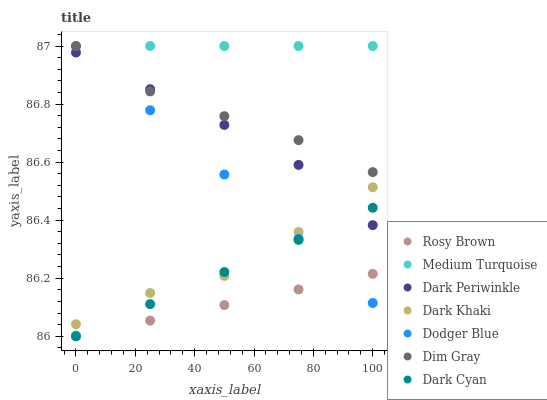Does Rosy Brown have the minimum area under the curve?
Answer yes or no. Yes. Does Medium Turquoise have the maximum area under the curve?
Answer yes or no. Yes. Does Dark Khaki have the minimum area under the curve?
Answer yes or no. No. Does Dark Khaki have the maximum area under the curve?
Answer yes or no. No. Is Rosy Brown the smoothest?
Answer yes or no. Yes. Is Medium Turquoise the roughest?
Answer yes or no. Yes. Is Dark Khaki the smoothest?
Answer yes or no. No. Is Dark Khaki the roughest?
Answer yes or no. No. Does Rosy Brown have the lowest value?
Answer yes or no. Yes. Does Dark Khaki have the lowest value?
Answer yes or no. No. Does Medium Turquoise have the highest value?
Answer yes or no. Yes. Does Dark Khaki have the highest value?
Answer yes or no. No. Is Dark Cyan less than Medium Turquoise?
Answer yes or no. Yes. Is Medium Turquoise greater than Rosy Brown?
Answer yes or no. Yes. Does Dodger Blue intersect Dim Gray?
Answer yes or no. Yes. Is Dodger Blue less than Dim Gray?
Answer yes or no. No. Is Dodger Blue greater than Dim Gray?
Answer yes or no. No. Does Dark Cyan intersect Medium Turquoise?
Answer yes or no. No. 